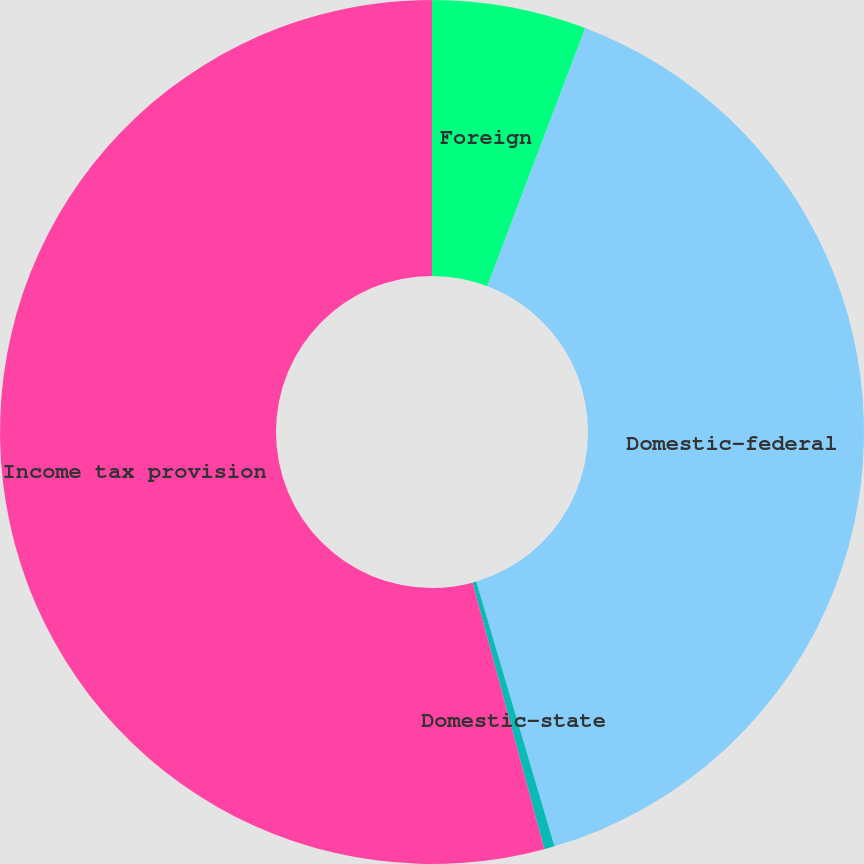<chart> <loc_0><loc_0><loc_500><loc_500><pie_chart><fcel>Foreign<fcel>Domestic-federal<fcel>Domestic-state<fcel>Income tax provision<nl><fcel>5.77%<fcel>39.65%<fcel>0.39%<fcel>54.18%<nl></chart> 